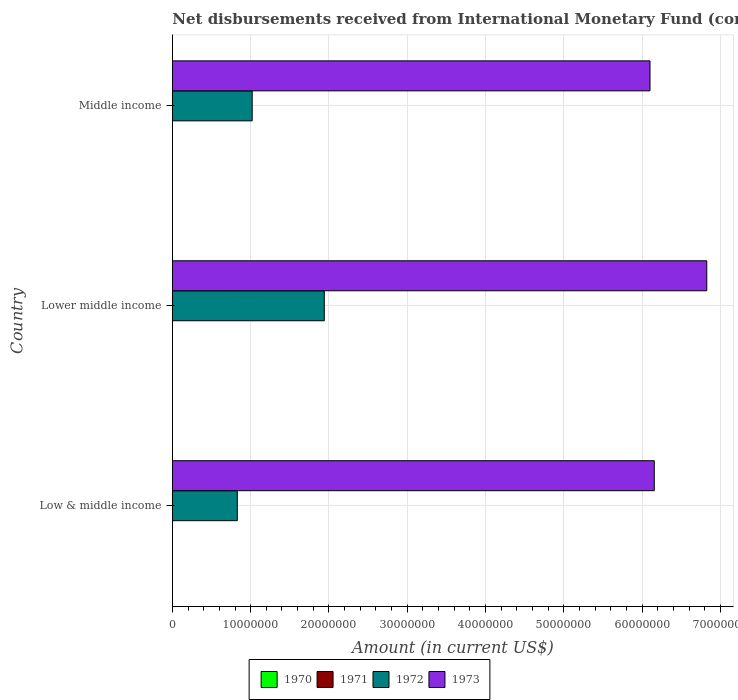How many different coloured bars are there?
Provide a short and direct response. 2. Are the number of bars per tick equal to the number of legend labels?
Make the answer very short. No. Are the number of bars on each tick of the Y-axis equal?
Provide a short and direct response. Yes. What is the label of the 2nd group of bars from the top?
Ensure brevity in your answer.  Lower middle income. What is the amount of disbursements received from International Monetary Fund in 1973 in Middle income?
Give a very brief answer. 6.10e+07. Across all countries, what is the maximum amount of disbursements received from International Monetary Fund in 1972?
Your answer should be very brief. 1.94e+07. Across all countries, what is the minimum amount of disbursements received from International Monetary Fund in 1972?
Make the answer very short. 8.30e+06. In which country was the amount of disbursements received from International Monetary Fund in 1973 maximum?
Offer a very short reply. Lower middle income. What is the difference between the amount of disbursements received from International Monetary Fund in 1973 in Low & middle income and that in Lower middle income?
Keep it short and to the point. -6.70e+06. What is the difference between the amount of disbursements received from International Monetary Fund in 1972 and amount of disbursements received from International Monetary Fund in 1973 in Low & middle income?
Your answer should be very brief. -5.33e+07. What is the ratio of the amount of disbursements received from International Monetary Fund in 1972 in Low & middle income to that in Middle income?
Your response must be concise. 0.81. Is the amount of disbursements received from International Monetary Fund in 1973 in Low & middle income less than that in Lower middle income?
Offer a very short reply. Yes. What is the difference between the highest and the second highest amount of disbursements received from International Monetary Fund in 1973?
Offer a very short reply. 6.70e+06. What is the difference between the highest and the lowest amount of disbursements received from International Monetary Fund in 1972?
Your answer should be very brief. 1.11e+07. In how many countries, is the amount of disbursements received from International Monetary Fund in 1972 greater than the average amount of disbursements received from International Monetary Fund in 1972 taken over all countries?
Make the answer very short. 1. Is the sum of the amount of disbursements received from International Monetary Fund in 1973 in Lower middle income and Middle income greater than the maximum amount of disbursements received from International Monetary Fund in 1970 across all countries?
Your answer should be very brief. Yes. Is it the case that in every country, the sum of the amount of disbursements received from International Monetary Fund in 1972 and amount of disbursements received from International Monetary Fund in 1971 is greater than the sum of amount of disbursements received from International Monetary Fund in 1970 and amount of disbursements received from International Monetary Fund in 1973?
Give a very brief answer. No. How many bars are there?
Your answer should be very brief. 6. Are all the bars in the graph horizontal?
Provide a succinct answer. Yes. How many countries are there in the graph?
Keep it short and to the point. 3. What is the difference between two consecutive major ticks on the X-axis?
Your answer should be very brief. 1.00e+07. How many legend labels are there?
Keep it short and to the point. 4. What is the title of the graph?
Ensure brevity in your answer.  Net disbursements received from International Monetary Fund (concessional). Does "1981" appear as one of the legend labels in the graph?
Provide a short and direct response. No. What is the label or title of the Y-axis?
Provide a short and direct response. Country. What is the Amount (in current US$) of 1971 in Low & middle income?
Offer a terse response. 0. What is the Amount (in current US$) of 1972 in Low & middle income?
Offer a very short reply. 8.30e+06. What is the Amount (in current US$) of 1973 in Low & middle income?
Ensure brevity in your answer.  6.16e+07. What is the Amount (in current US$) of 1970 in Lower middle income?
Ensure brevity in your answer.  0. What is the Amount (in current US$) in 1972 in Lower middle income?
Your answer should be compact. 1.94e+07. What is the Amount (in current US$) in 1973 in Lower middle income?
Offer a very short reply. 6.83e+07. What is the Amount (in current US$) in 1970 in Middle income?
Provide a succinct answer. 0. What is the Amount (in current US$) in 1972 in Middle income?
Your answer should be compact. 1.02e+07. What is the Amount (in current US$) in 1973 in Middle income?
Provide a short and direct response. 6.10e+07. Across all countries, what is the maximum Amount (in current US$) in 1972?
Give a very brief answer. 1.94e+07. Across all countries, what is the maximum Amount (in current US$) of 1973?
Ensure brevity in your answer.  6.83e+07. Across all countries, what is the minimum Amount (in current US$) in 1972?
Ensure brevity in your answer.  8.30e+06. Across all countries, what is the minimum Amount (in current US$) of 1973?
Provide a succinct answer. 6.10e+07. What is the total Amount (in current US$) of 1972 in the graph?
Provide a short and direct response. 3.79e+07. What is the total Amount (in current US$) in 1973 in the graph?
Make the answer very short. 1.91e+08. What is the difference between the Amount (in current US$) in 1972 in Low & middle income and that in Lower middle income?
Your answer should be compact. -1.11e+07. What is the difference between the Amount (in current US$) of 1973 in Low & middle income and that in Lower middle income?
Provide a short and direct response. -6.70e+06. What is the difference between the Amount (in current US$) of 1972 in Low & middle income and that in Middle income?
Provide a succinct answer. -1.90e+06. What is the difference between the Amount (in current US$) in 1973 in Low & middle income and that in Middle income?
Ensure brevity in your answer.  5.46e+05. What is the difference between the Amount (in current US$) in 1972 in Lower middle income and that in Middle income?
Ensure brevity in your answer.  9.21e+06. What is the difference between the Amount (in current US$) in 1973 in Lower middle income and that in Middle income?
Provide a succinct answer. 7.25e+06. What is the difference between the Amount (in current US$) in 1972 in Low & middle income and the Amount (in current US$) in 1973 in Lower middle income?
Make the answer very short. -6.00e+07. What is the difference between the Amount (in current US$) of 1972 in Low & middle income and the Amount (in current US$) of 1973 in Middle income?
Offer a very short reply. -5.27e+07. What is the difference between the Amount (in current US$) in 1972 in Lower middle income and the Amount (in current US$) in 1973 in Middle income?
Ensure brevity in your answer.  -4.16e+07. What is the average Amount (in current US$) in 1970 per country?
Provide a succinct answer. 0. What is the average Amount (in current US$) in 1972 per country?
Your answer should be very brief. 1.26e+07. What is the average Amount (in current US$) in 1973 per country?
Provide a short and direct response. 6.36e+07. What is the difference between the Amount (in current US$) in 1972 and Amount (in current US$) in 1973 in Low & middle income?
Provide a short and direct response. -5.33e+07. What is the difference between the Amount (in current US$) of 1972 and Amount (in current US$) of 1973 in Lower middle income?
Keep it short and to the point. -4.89e+07. What is the difference between the Amount (in current US$) in 1972 and Amount (in current US$) in 1973 in Middle income?
Provide a succinct answer. -5.08e+07. What is the ratio of the Amount (in current US$) of 1972 in Low & middle income to that in Lower middle income?
Keep it short and to the point. 0.43. What is the ratio of the Amount (in current US$) in 1973 in Low & middle income to that in Lower middle income?
Your response must be concise. 0.9. What is the ratio of the Amount (in current US$) of 1972 in Low & middle income to that in Middle income?
Offer a very short reply. 0.81. What is the ratio of the Amount (in current US$) in 1973 in Low & middle income to that in Middle income?
Offer a terse response. 1.01. What is the ratio of the Amount (in current US$) of 1972 in Lower middle income to that in Middle income?
Provide a short and direct response. 1.9. What is the ratio of the Amount (in current US$) in 1973 in Lower middle income to that in Middle income?
Keep it short and to the point. 1.12. What is the difference between the highest and the second highest Amount (in current US$) of 1972?
Offer a very short reply. 9.21e+06. What is the difference between the highest and the second highest Amount (in current US$) of 1973?
Ensure brevity in your answer.  6.70e+06. What is the difference between the highest and the lowest Amount (in current US$) of 1972?
Your response must be concise. 1.11e+07. What is the difference between the highest and the lowest Amount (in current US$) in 1973?
Your answer should be very brief. 7.25e+06. 